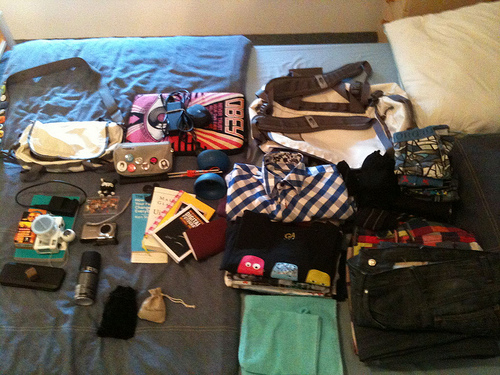<image>
Is there a diabolo on the bed? Yes. Looking at the image, I can see the diabolo is positioned on top of the bed, with the bed providing support. 